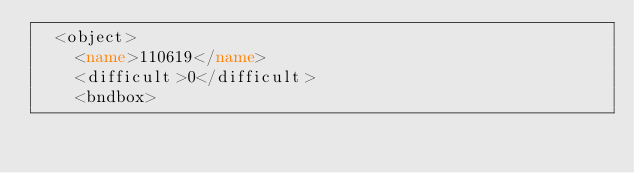Convert code to text. <code><loc_0><loc_0><loc_500><loc_500><_XML_>  <object>
    <name>110619</name>
    <difficult>0</difficult>
    <bndbox></code> 